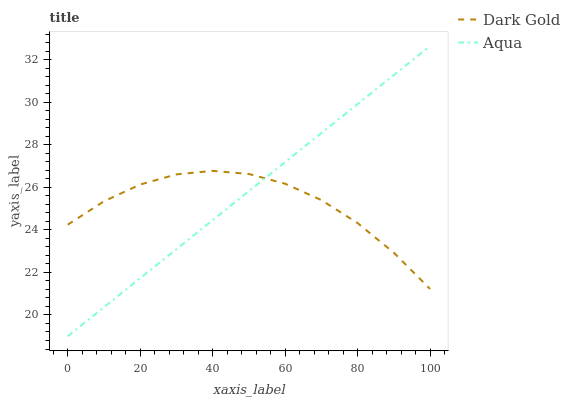Does Dark Gold have the maximum area under the curve?
Answer yes or no. No. Is Dark Gold the smoothest?
Answer yes or no. No. Does Dark Gold have the lowest value?
Answer yes or no. No. Does Dark Gold have the highest value?
Answer yes or no. No. 